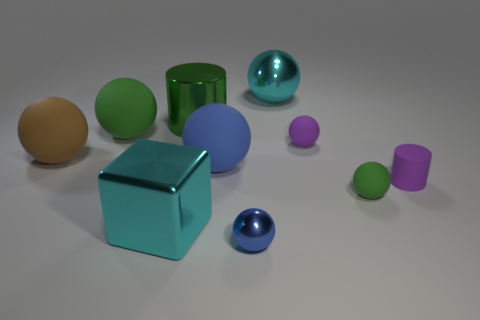Subtract 3 balls. How many balls are left? 4 Subtract all green balls. How many balls are left? 5 Subtract all green balls. How many balls are left? 5 Subtract all green balls. Subtract all yellow blocks. How many balls are left? 5 Subtract all balls. How many objects are left? 3 Subtract all tiny matte spheres. Subtract all tiny blue spheres. How many objects are left? 7 Add 9 green shiny things. How many green shiny things are left? 10 Add 6 green rubber spheres. How many green rubber spheres exist? 8 Subtract 0 red balls. How many objects are left? 10 